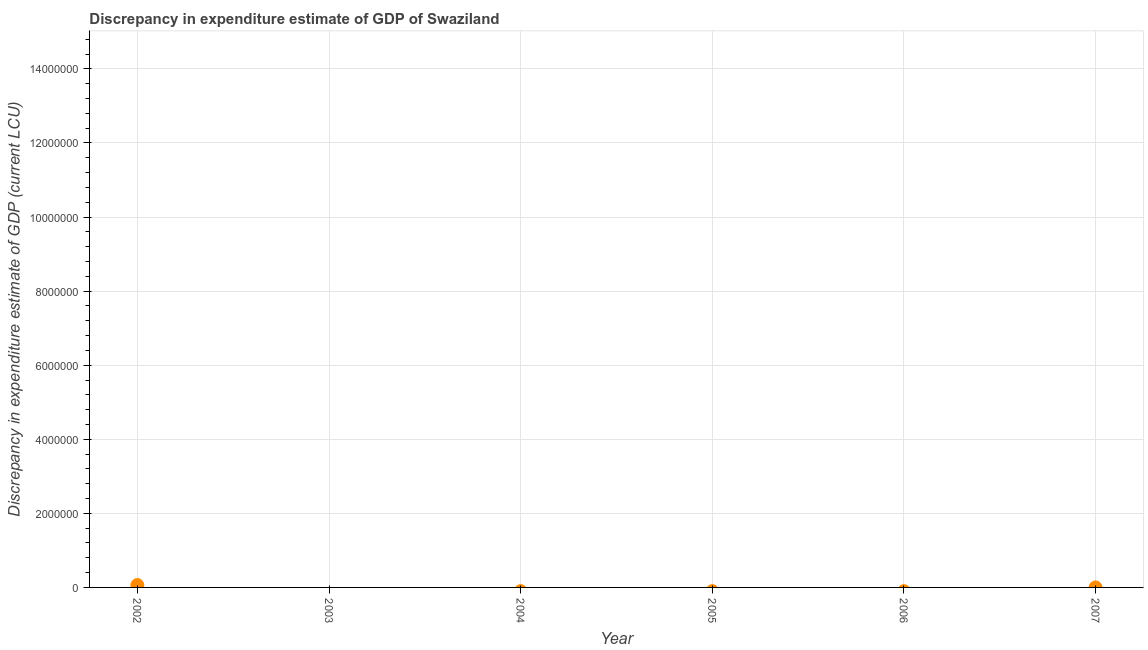Across all years, what is the maximum discrepancy in expenditure estimate of gdp?
Your response must be concise. 6.47e+04. Across all years, what is the minimum discrepancy in expenditure estimate of gdp?
Offer a terse response. 0. What is the sum of the discrepancy in expenditure estimate of gdp?
Offer a very short reply. 6.47e+04. What is the average discrepancy in expenditure estimate of gdp per year?
Offer a very short reply. 1.08e+04. In how many years, is the discrepancy in expenditure estimate of gdp greater than 14000000 LCU?
Ensure brevity in your answer.  0. What is the ratio of the discrepancy in expenditure estimate of gdp in 2002 to that in 2007?
Ensure brevity in your answer.  3.24e+1. Is the difference between the discrepancy in expenditure estimate of gdp in 2002 and 2007 greater than the difference between any two years?
Make the answer very short. No. What is the difference between the highest and the lowest discrepancy in expenditure estimate of gdp?
Offer a terse response. 6.47e+04. In how many years, is the discrepancy in expenditure estimate of gdp greater than the average discrepancy in expenditure estimate of gdp taken over all years?
Your response must be concise. 1. Does the discrepancy in expenditure estimate of gdp monotonically increase over the years?
Make the answer very short. No. What is the difference between two consecutive major ticks on the Y-axis?
Give a very brief answer. 2.00e+06. Does the graph contain grids?
Give a very brief answer. Yes. What is the title of the graph?
Make the answer very short. Discrepancy in expenditure estimate of GDP of Swaziland. What is the label or title of the X-axis?
Offer a terse response. Year. What is the label or title of the Y-axis?
Offer a terse response. Discrepancy in expenditure estimate of GDP (current LCU). What is the Discrepancy in expenditure estimate of GDP (current LCU) in 2002?
Your answer should be compact. 6.47e+04. What is the Discrepancy in expenditure estimate of GDP (current LCU) in 2004?
Provide a short and direct response. 0. What is the Discrepancy in expenditure estimate of GDP (current LCU) in 2006?
Your answer should be compact. 0. What is the Discrepancy in expenditure estimate of GDP (current LCU) in 2007?
Provide a short and direct response. 2e-6. What is the difference between the Discrepancy in expenditure estimate of GDP (current LCU) in 2002 and 2007?
Your answer should be compact. 6.47e+04. What is the ratio of the Discrepancy in expenditure estimate of GDP (current LCU) in 2002 to that in 2007?
Provide a short and direct response. 3.24e+1. 